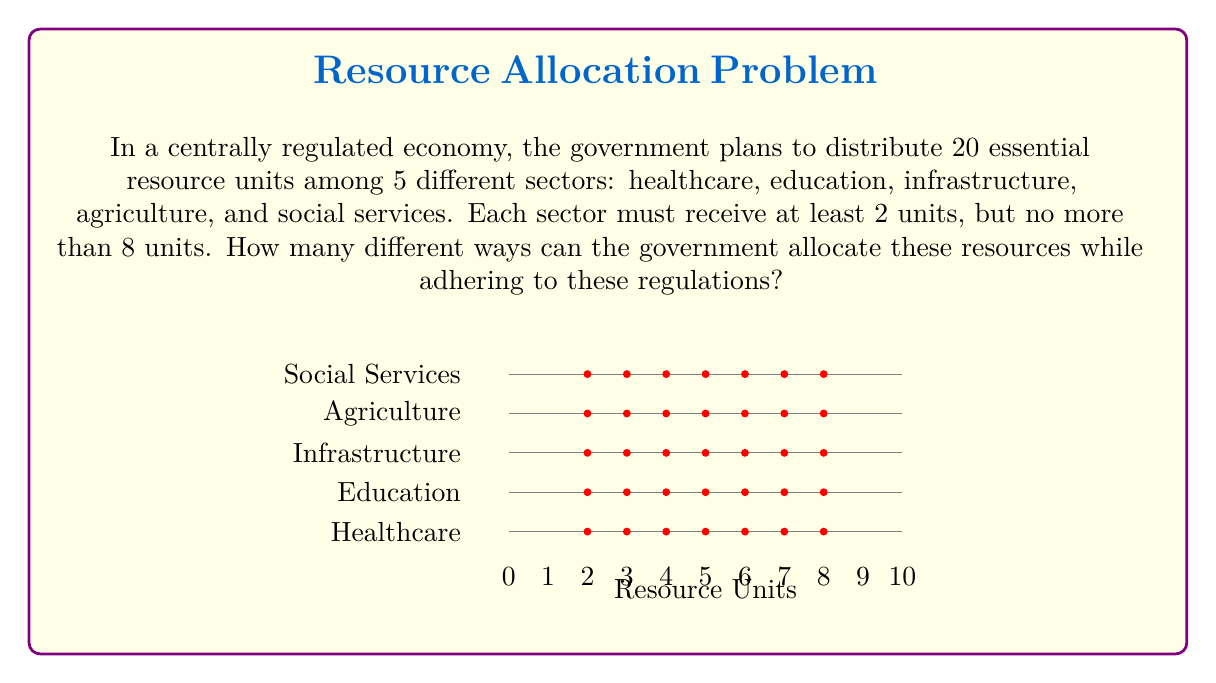Give your solution to this math problem. Let's approach this step-by-step using combinatorics:

1) This is a problem of distributing identical objects (resource units) into distinct containers (sectors) with constraints. We can use the stars and bars method with modifications.

2) First, we need to account for the minimum 2 units per sector:
   $20 - (2 \times 5) = 10$ units left to distribute

3) Now we need to distribute 10 units among 5 sectors, with each sector receiving at most 6 additional units (to stay within the 8-unit maximum).

4) This is equivalent to finding the number of non-negative integer solutions to:
   $x_1 + x_2 + x_3 + x_4 + x_5 = 10$, where $0 \leq x_i \leq 6$ for all $i$

5) We can solve this using the principle of inclusion-exclusion:

   Let $A_i$ be the set of solutions where $x_i \geq 7$

   $|A_i| = \binom{10 - 7 + 4}{4} = \binom{7}{4} = 35$ for each $i$

6) The total number of solutions is:

   $$\binom{10+5-1}{5-1} - \binom{5}{1}\binom{7}{4} + \binom{5}{2}\binom{4}{4} - \binom{5}{3}\binom{1}{4} + \binom{5}{4}\binom{-2}{4} - \binom{5}{5}\binom{-5}{4}$$

7) Calculating:
   $$\binom{14}{4} - 5 \times 35 + 10 \times 1 - 0 + 0 - 0$$
   $$= 1001 - 175 + 10 = 836$$

Therefore, there are 836 different ways to allocate the resources.
Answer: 836 